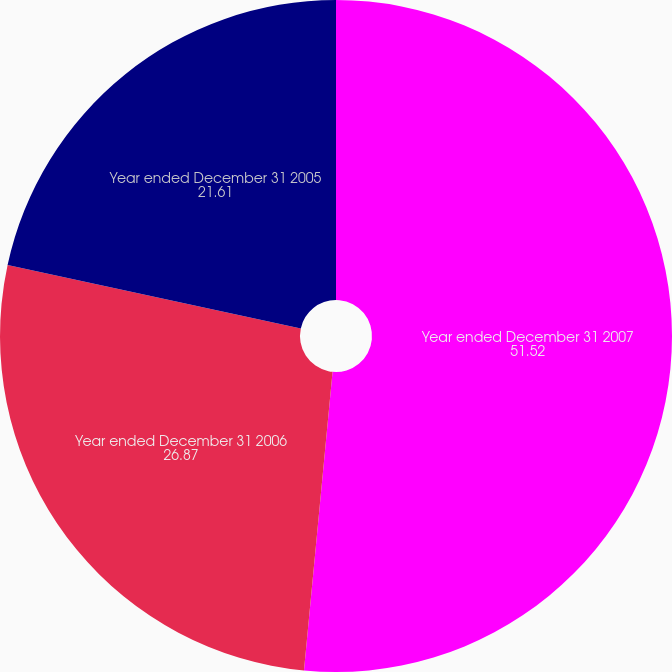Convert chart. <chart><loc_0><loc_0><loc_500><loc_500><pie_chart><fcel>Year ended December 31 2007<fcel>Year ended December 31 2006<fcel>Year ended December 31 2005<nl><fcel>51.52%<fcel>26.87%<fcel>21.61%<nl></chart> 